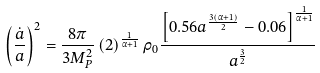Convert formula to latex. <formula><loc_0><loc_0><loc_500><loc_500>\left ( \frac { \dot { a } } { a } \right ) ^ { 2 } = \frac { 8 \pi } { 3 M _ { P } ^ { 2 } } \left ( 2 \right ) ^ { \frac { 1 } { \alpha + 1 } } \rho _ { 0 } \frac { \left [ 0 . 5 6 a ^ { \frac { 3 \left ( \alpha + 1 \right ) } { 2 } } - 0 . 0 6 \right ] ^ { \frac { 1 } { \alpha + 1 } } } { a ^ { \frac { 3 } { 2 } } }</formula> 